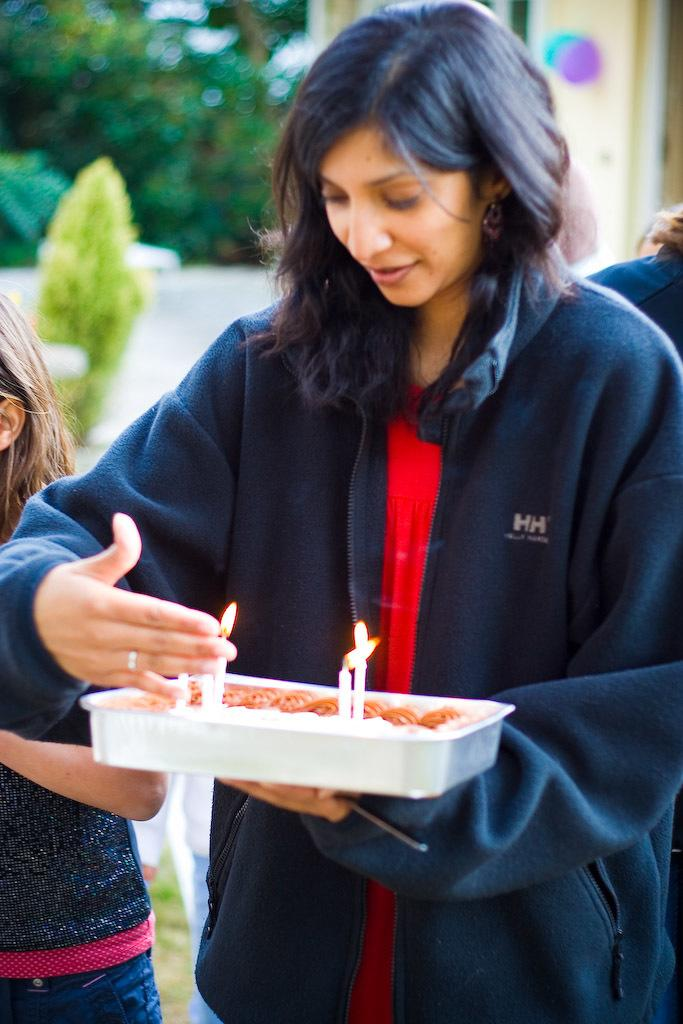What is the woman in the image doing? The woman is standing in the image and holding a container. What else can be seen in the image besides the woman? There are candles and persons behind the woman in the image. What type of question is being asked by the dirt in the image? There is no dirt present in the image, and therefore no question can be asked by it. 